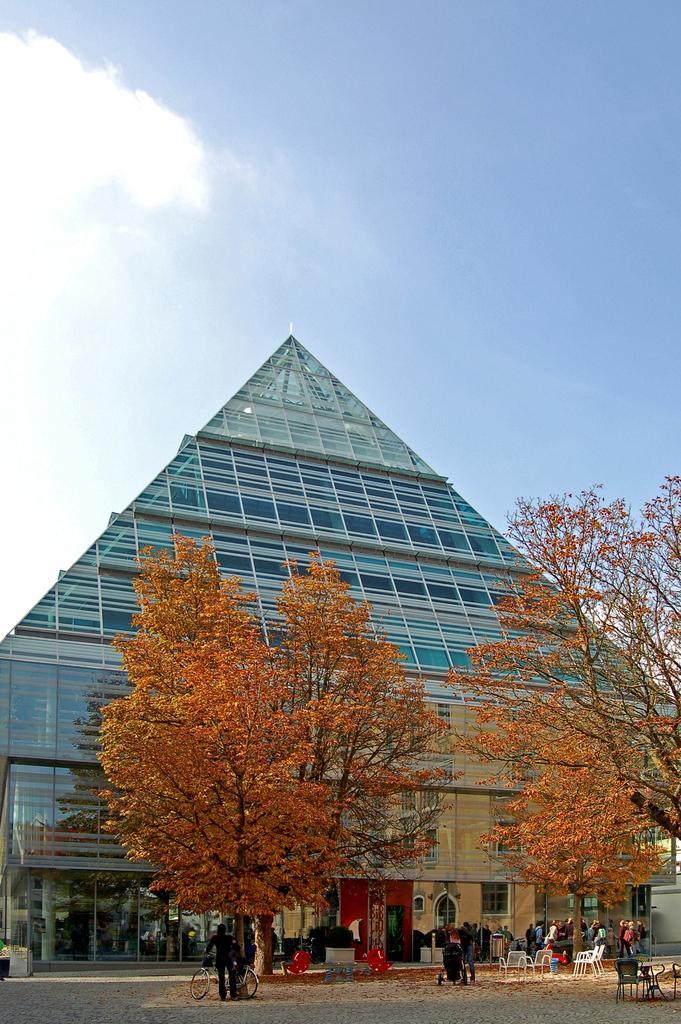Can you describe this image briefly? In this image we can see a building and there are few trees in front of the building and we can see some people and there are some chairs and other objects on the ground. There is a person standing near the bicycle and at the top we can see the sky with clouds. 